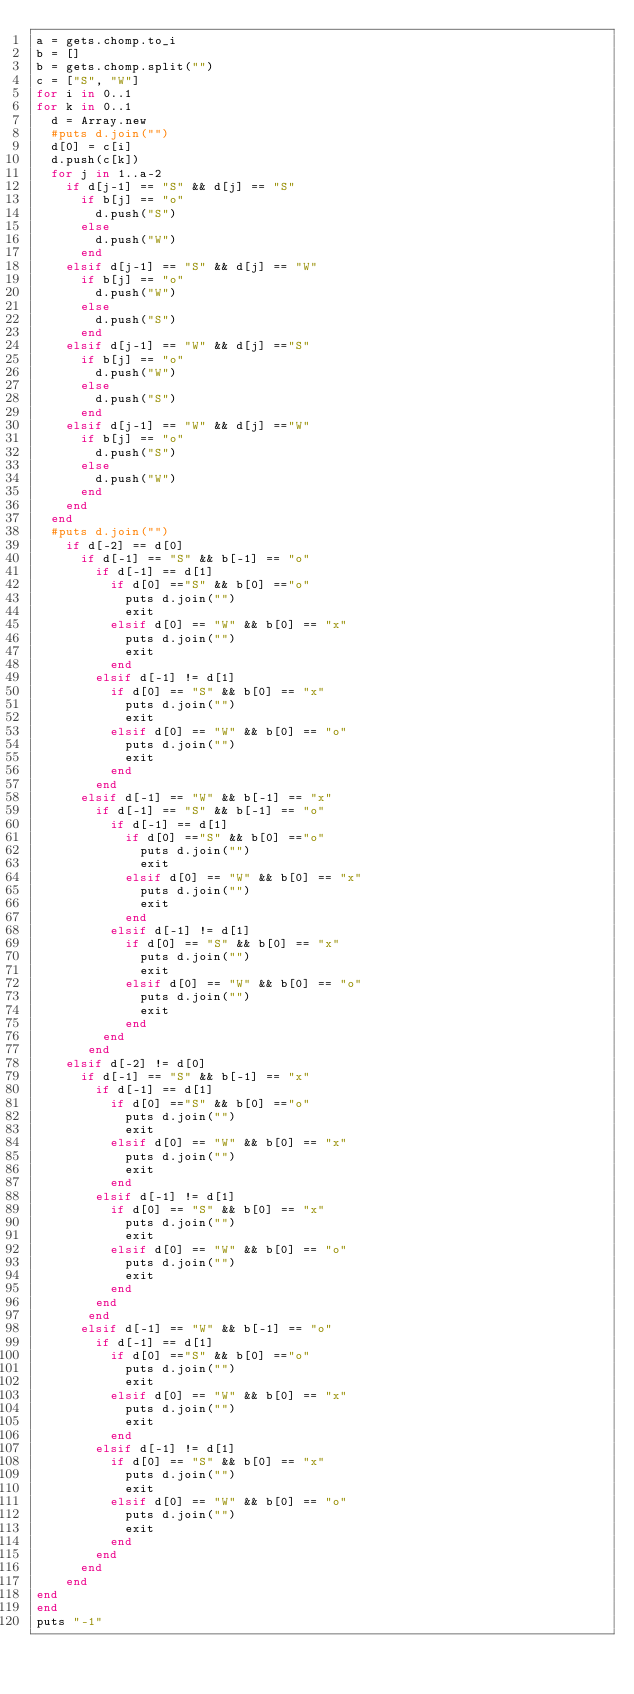Convert code to text. <code><loc_0><loc_0><loc_500><loc_500><_Ruby_>a = gets.chomp.to_i
b = []
b = gets.chomp.split("")
c = ["S", "W"]
for i in 0..1
for k in 0..1
  d = Array.new
  #puts d.join("")
  d[0] = c[i]
  d.push(c[k])
  for j in 1..a-2
    if d[j-1] == "S" && d[j] == "S"
      if b[j] == "o"
        d.push("S")
      else
        d.push("W")
      end
    elsif d[j-1] == "S" && d[j] == "W"
      if b[j] == "o"
        d.push("W")
      else
        d.push("S")
      end
    elsif d[j-1] == "W" && d[j] =="S"
      if b[j] == "o"
        d.push("W")
      else
        d.push("S")
      end
    elsif d[j-1] == "W" && d[j] =="W"
      if b[j] == "o"
        d.push("S")
      else
        d.push("W")
      end
    end
  end
  #puts d.join("")
    if d[-2] == d[0]
      if d[-1] == "S" && b[-1] == "o"
        if d[-1] == d[1]
          if d[0] =="S" && b[0] =="o"
            puts d.join("")
            exit
          elsif d[0] == "W" && b[0] == "x"
            puts d.join("")
            exit
          end
        elsif d[-1] != d[1]
          if d[0] == "S" && b[0] == "x"
            puts d.join("")
            exit
          elsif d[0] == "W" && b[0] == "o"
            puts d.join("")
            exit
          end
        end
      elsif d[-1] == "W" && b[-1] == "x"
        if d[-1] == "S" && b[-1] == "o"
          if d[-1] == d[1]
            if d[0] =="S" && b[0] =="o"
              puts d.join("")
              exit
            elsif d[0] == "W" && b[0] == "x"
              puts d.join("")
              exit
            end
          elsif d[-1] != d[1]
            if d[0] == "S" && b[0] == "x"
              puts d.join("")
              exit
            elsif d[0] == "W" && b[0] == "o"
              puts d.join("")
              exit
            end
         end
       end
    elsif d[-2] != d[0]
      if d[-1] == "S" && b[-1] == "x"
        if d[-1] == d[1]
          if d[0] =="S" && b[0] =="o"
            puts d.join("")
            exit
          elsif d[0] == "W" && b[0] == "x"
            puts d.join("")
            exit
          end
        elsif d[-1] != d[1]
          if d[0] == "S" && b[0] == "x"
            puts d.join("")
            exit
          elsif d[0] == "W" && b[0] == "o"
            puts d.join("")
            exit
          end
        end
       end
      elsif d[-1] == "W" && b[-1] == "o"
        if d[-1] == d[1]
          if d[0] =="S" && b[0] =="o"
            puts d.join("")
            exit
          elsif d[0] == "W" && b[0] == "x"
            puts d.join("")
            exit
          end
        elsif d[-1] != d[1]
          if d[0] == "S" && b[0] == "x"
            puts d.join("")
            exit
          elsif d[0] == "W" && b[0] == "o"
            puts d.join("")
            exit
          end
        end
      end
    end
end
end
puts "-1"
      </code> 